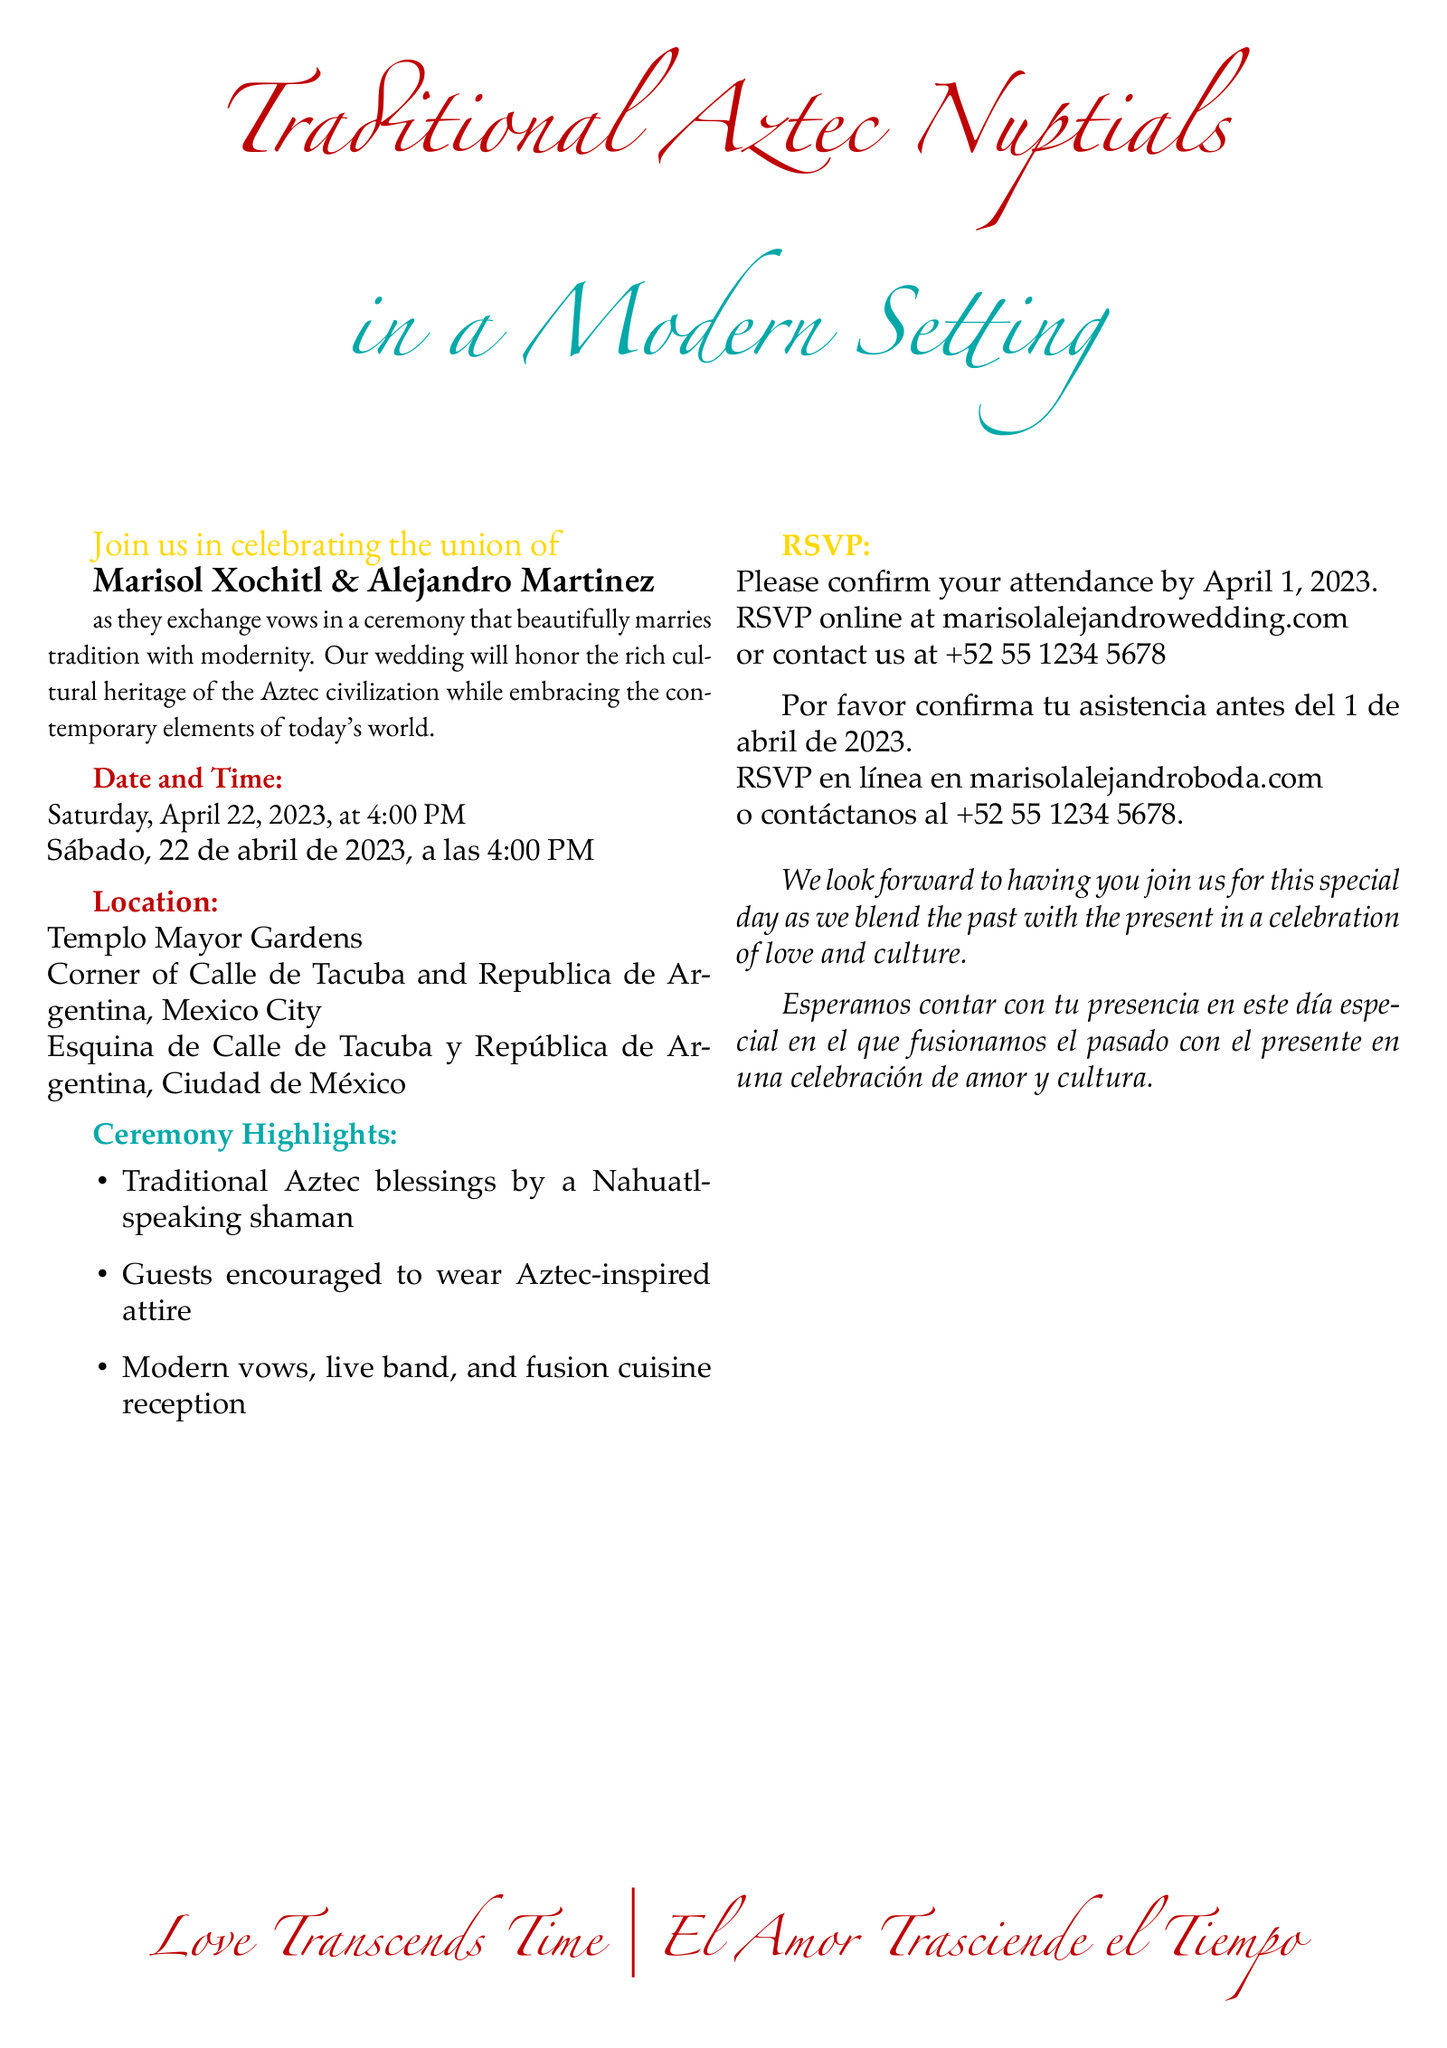What is the date of the wedding? The document specifies that the wedding is on Saturday, April 22, 2023.
Answer: April 22, 2023 Who are the couple getting married? The names of the couple listed in the invitation are Marisol Xochitl and Alejandro Martinez.
Answer: Marisol Xochitl & Alejandro Martinez Where is the location of the ceremony? The invitation states the location as Templo Mayor Gardens, Mexico City.
Answer: Templo Mayor Gardens What time does the ceremony begin? The document indicates that the ceremony starts at 4:00 PM.
Answer: 4:00 PM What type of attire is encouraged for guests? The invitation encourages guests to wear Aztec-inspired attire.
Answer: Aztec-inspired attire What language is used alongside Spanish in the invitation? The invitation uses Nahuatl as part of the cultural elements.
Answer: Nahuatl By what date should guests RSVP? The document mentions that guests should confirm their attendance by April 1, 2023.
Answer: April 1, 2023 What type of music will be at the reception? The invitation states that there will be a live band at the reception.
Answer: Live band What cultural element is highlighted during the ceremony? The ceremony features traditional Aztec blessings performed by a shaman.
Answer: Traditional Aztec blessings 